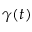<formula> <loc_0><loc_0><loc_500><loc_500>\gamma ( t )</formula> 